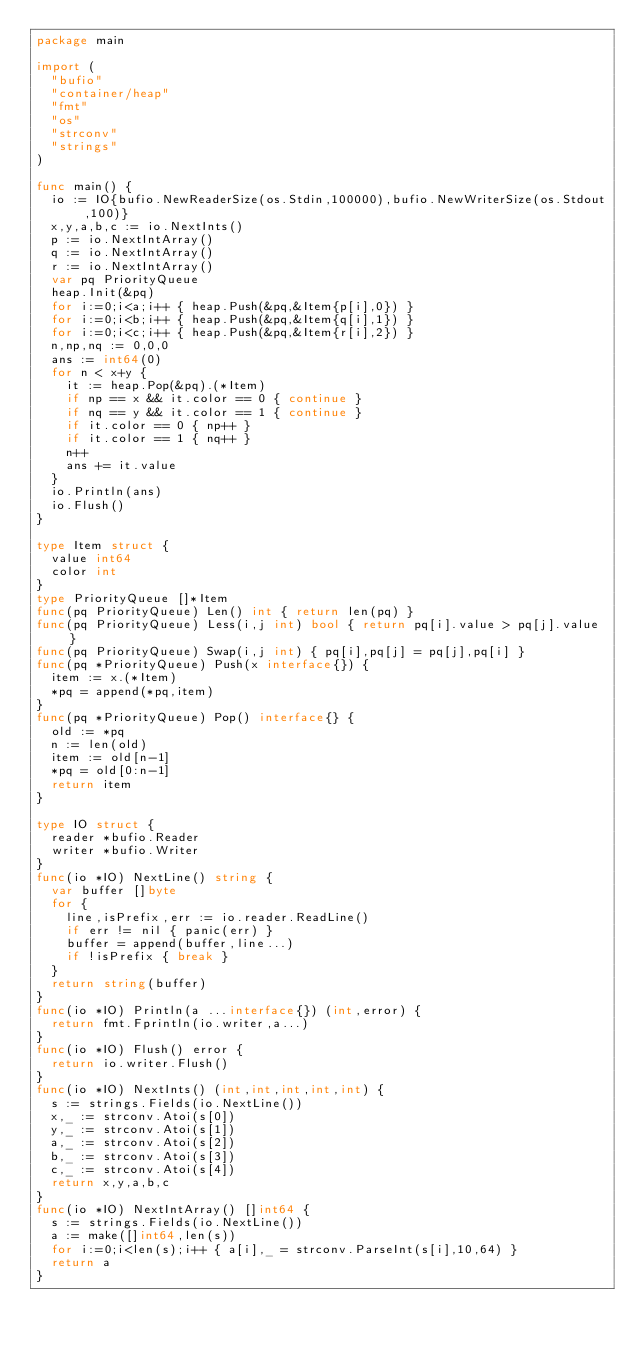<code> <loc_0><loc_0><loc_500><loc_500><_Go_>package main

import (
  "bufio"
  "container/heap"
  "fmt"
  "os"
  "strconv"
  "strings"
)

func main() {
  io := IO{bufio.NewReaderSize(os.Stdin,100000),bufio.NewWriterSize(os.Stdout,100)}
  x,y,a,b,c := io.NextInts()
  p := io.NextIntArray()
  q := io.NextIntArray()
  r := io.NextIntArray()
  var pq PriorityQueue
  heap.Init(&pq)
  for i:=0;i<a;i++ { heap.Push(&pq,&Item{p[i],0}) }
  for i:=0;i<b;i++ { heap.Push(&pq,&Item{q[i],1}) }
  for i:=0;i<c;i++ { heap.Push(&pq,&Item{r[i],2}) }
  n,np,nq := 0,0,0
  ans := int64(0)
  for n < x+y {
    it := heap.Pop(&pq).(*Item)
    if np == x && it.color == 0 { continue }
    if nq == y && it.color == 1 { continue }
    if it.color == 0 { np++ }
    if it.color == 1 { nq++ }
    n++
    ans += it.value
  }
  io.Println(ans)
  io.Flush()
}

type Item struct {
  value int64
  color int
}
type PriorityQueue []*Item
func(pq PriorityQueue) Len() int { return len(pq) }
func(pq PriorityQueue) Less(i,j int) bool { return pq[i].value > pq[j].value }
func(pq PriorityQueue) Swap(i,j int) { pq[i],pq[j] = pq[j],pq[i] }
func(pq *PriorityQueue) Push(x interface{}) {
  item := x.(*Item)
  *pq = append(*pq,item)
}
func(pq *PriorityQueue) Pop() interface{} {
  old := *pq
  n := len(old)
  item := old[n-1]
  *pq = old[0:n-1]
  return item
}

type IO struct {
  reader *bufio.Reader
  writer *bufio.Writer
}
func(io *IO) NextLine() string {
  var buffer []byte
  for {
    line,isPrefix,err := io.reader.ReadLine()
    if err != nil { panic(err) }
    buffer = append(buffer,line...)
    if !isPrefix { break }
  }
  return string(buffer)
}
func(io *IO) Println(a ...interface{}) (int,error) {
  return fmt.Fprintln(io.writer,a...)
}
func(io *IO) Flush() error {
  return io.writer.Flush()
}
func(io *IO) NextInts() (int,int,int,int,int) {
  s := strings.Fields(io.NextLine())
  x,_ := strconv.Atoi(s[0])
  y,_ := strconv.Atoi(s[1])
  a,_ := strconv.Atoi(s[2])
  b,_ := strconv.Atoi(s[3])
  c,_ := strconv.Atoi(s[4])
  return x,y,a,b,c
}
func(io *IO) NextIntArray() []int64 {
  s := strings.Fields(io.NextLine())
  a := make([]int64,len(s))
  for i:=0;i<len(s);i++ { a[i],_ = strconv.ParseInt(s[i],10,64) }
  return a
}
</code> 